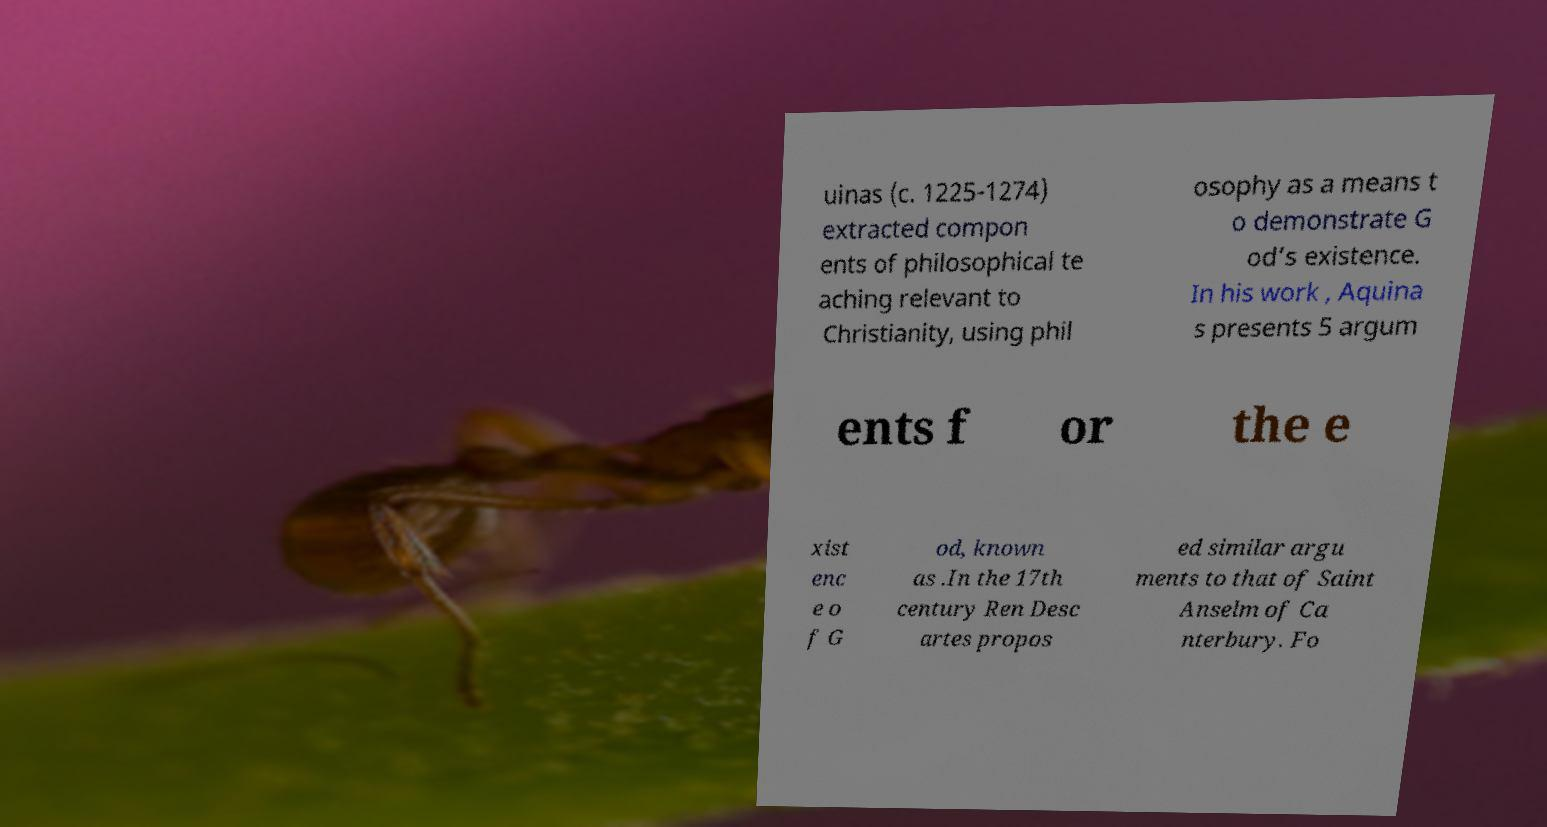Can you accurately transcribe the text from the provided image for me? uinas (c. 1225-1274) extracted compon ents of philosophical te aching relevant to Christianity, using phil osophy as a means t o demonstrate G od’s existence. In his work , Aquina s presents 5 argum ents f or the e xist enc e o f G od, known as .In the 17th century Ren Desc artes propos ed similar argu ments to that of Saint Anselm of Ca nterbury. Fo 